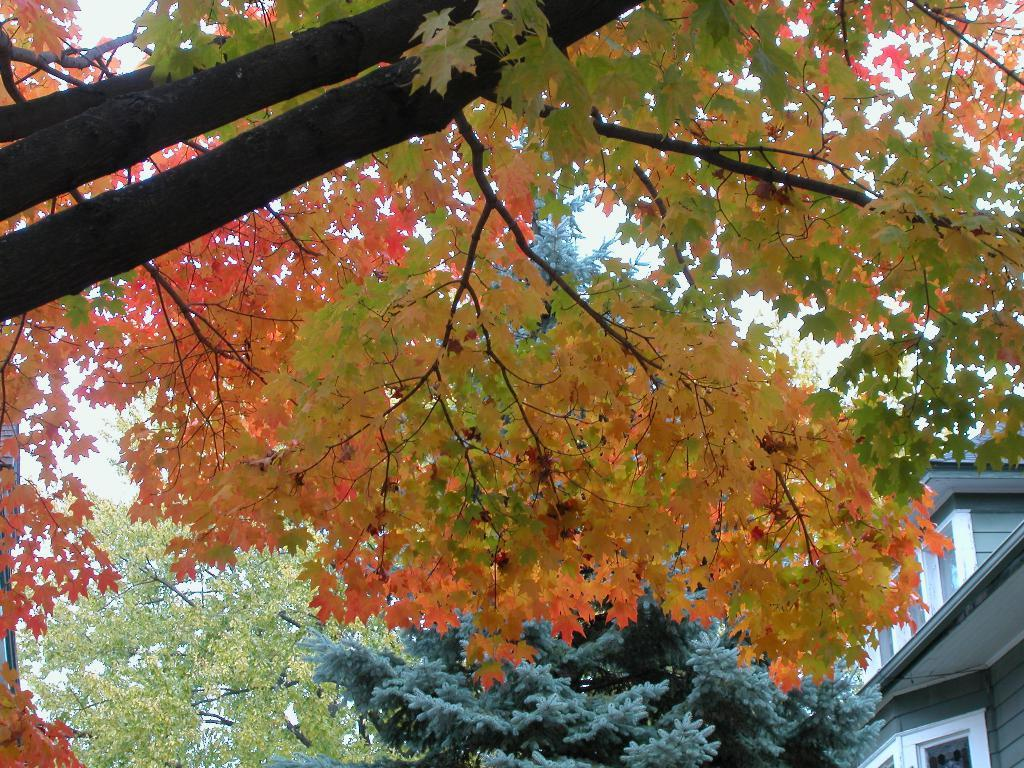What type of natural environment is depicted in the image? There are many trees in the image, indicating a forest or wooded area. What else can be seen in the sky in the image? The sky is visible in the image, but no specific details about clouds or weather conditions are mentioned. What type of structure is present in the image? There is a house in the image. What type of farm animals can be seen grazing in the image? There is no mention of farm animals or a farm in the image; it primarily features trees and a house. 